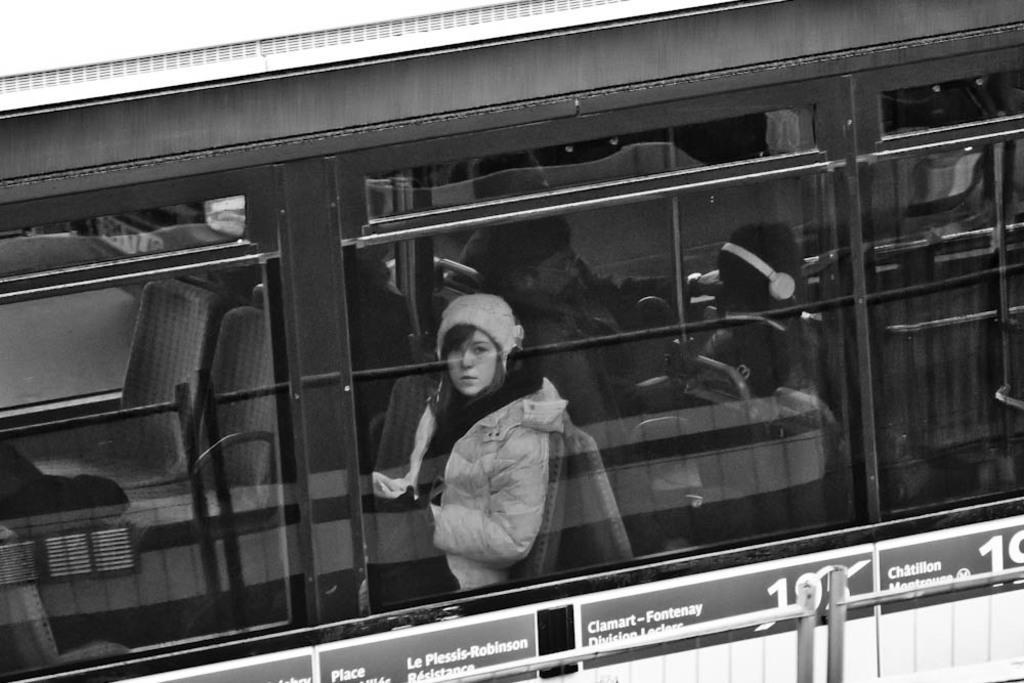How would you summarize this image in a sentence or two? This is a black and white image. In this image, we can see a bus. On the bus, we can see a woman sitting, glass window, chairs. At the top, we can see white color, at the bottom, we can see white color. 